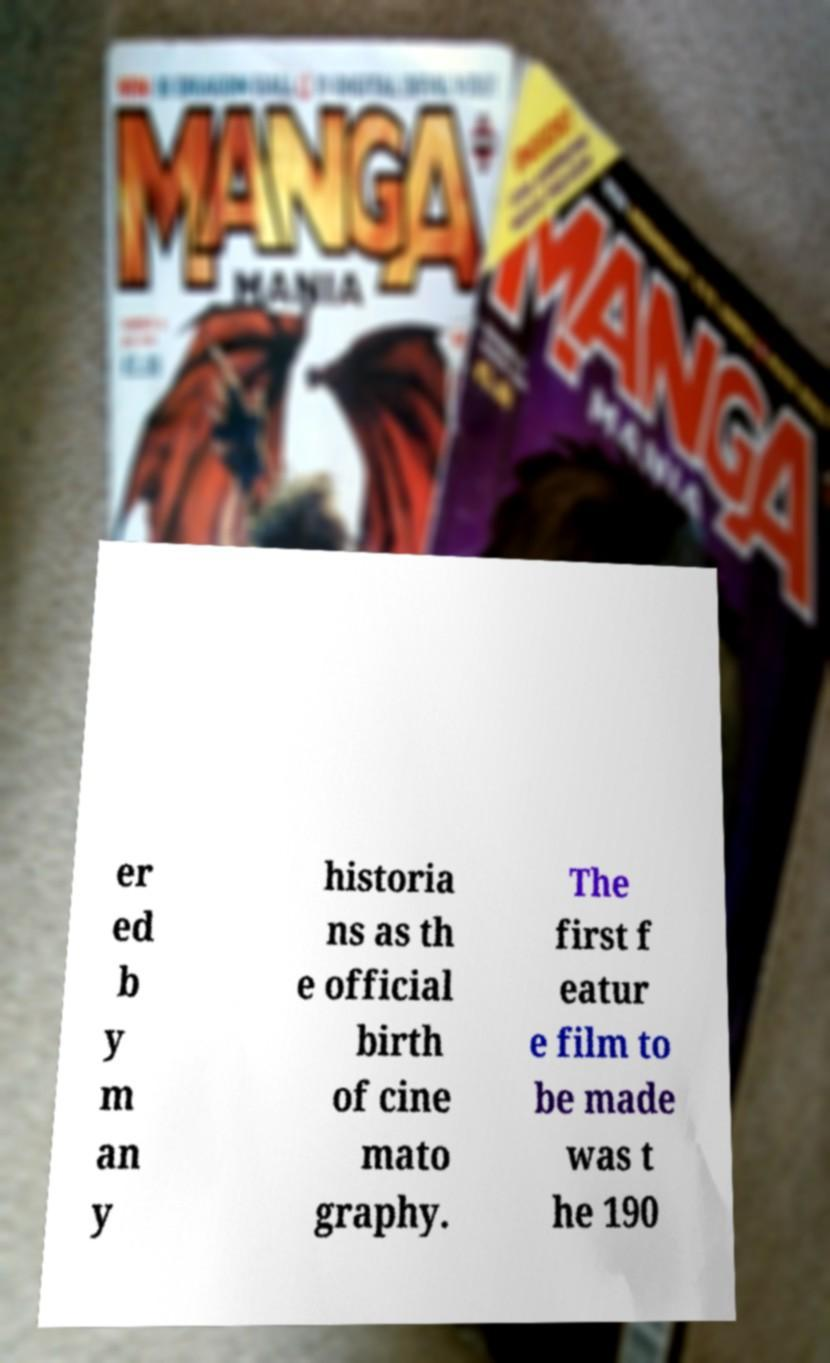Please read and relay the text visible in this image. What does it say? er ed b y m an y historia ns as th e official birth of cine mato graphy. The first f eatur e film to be made was t he 190 